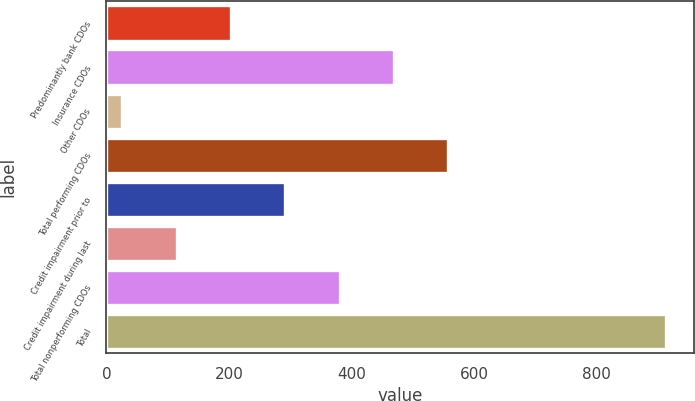Convert chart. <chart><loc_0><loc_0><loc_500><loc_500><bar_chart><fcel>Predominantly bank CDOs<fcel>Insurance CDOs<fcel>Other CDOs<fcel>Total performing CDOs<fcel>Credit impairment prior to<fcel>Credit impairment during last<fcel>Total nonperforming CDOs<fcel>Total<nl><fcel>203.4<fcel>469.5<fcel>26<fcel>558.2<fcel>292.1<fcel>114.7<fcel>380.8<fcel>913<nl></chart> 